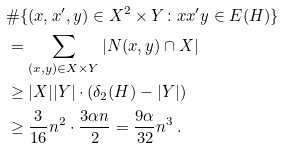Convert formula to latex. <formula><loc_0><loc_0><loc_500><loc_500>& \# \{ ( x , x ^ { \prime } , y ) \in X ^ { 2 } \times Y \colon x x ^ { \prime } y \in E ( H ) \} \\ & = \sum _ { ( x , y ) \in X \times Y } | N ( x , y ) \cap X | \\ & \geq | X | | Y | \cdot ( \delta _ { 2 } ( H ) - | Y | ) \\ & \geq \frac { 3 } { 1 6 } n ^ { 2 } \cdot \frac { 3 \alpha n } { 2 } = \frac { 9 \alpha } { 3 2 } n ^ { 3 } \, .</formula> 